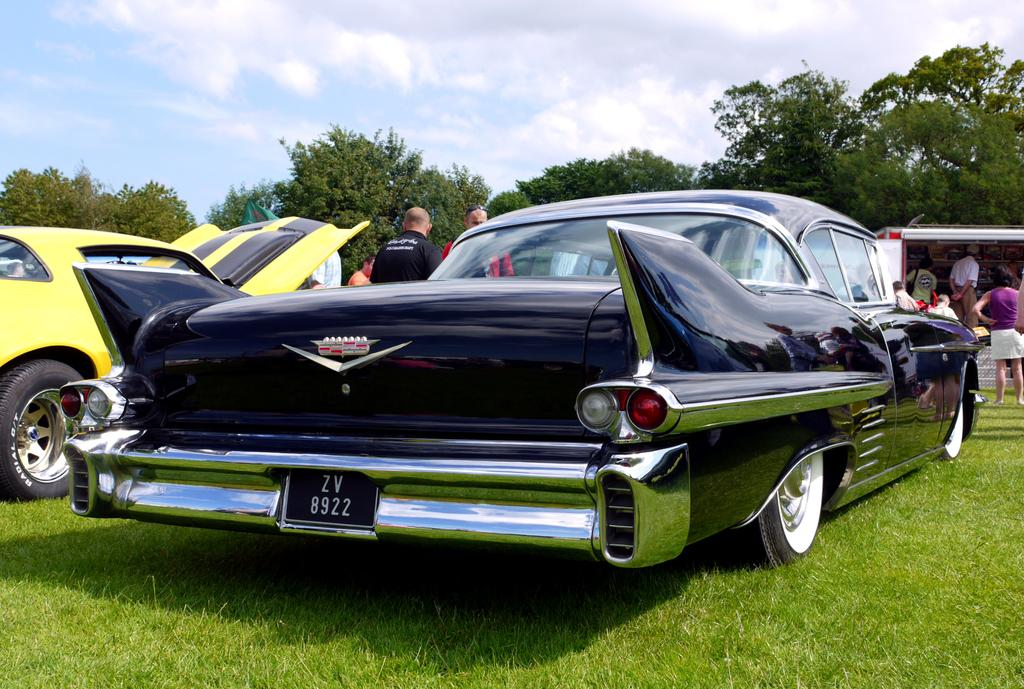What is the main subject of the image? The main subject of the image is cars on a grassland. What can be seen in the background of the image? In the background of the image, there are people standing and trees visible. What else is visible in the background of the image? The sky is also visible in the background of the image. What type of weather event is happening in the image? There is no indication of a weather event in the image; it simply shows cars on a grassland with people, trees, and the sky visible in the background. 